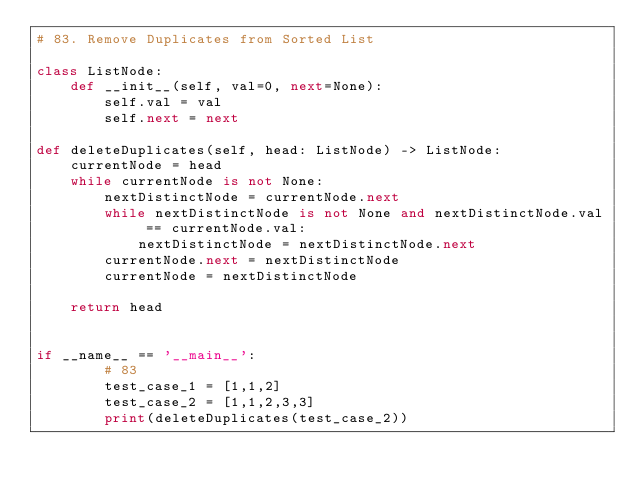Convert code to text. <code><loc_0><loc_0><loc_500><loc_500><_Python_># 83. Remove Duplicates from Sorted List

class ListNode:
    def __init__(self, val=0, next=None):
        self.val = val
        self.next = next

def deleteDuplicates(self, head: ListNode) -> ListNode:
    currentNode = head
    while currentNode is not None:
        nextDistinctNode = currentNode.next
        while nextDistinctNode is not None and nextDistinctNode.val == currentNode.val:
            nextDistinctNode = nextDistinctNode.next
        currentNode.next = nextDistinctNode
        currentNode = nextDistinctNode
    
    return head


if __name__ == '__main__':
        # 83
        test_case_1 = [1,1,2]
        test_case_2 = [1,1,2,3,3]
        print(deleteDuplicates(test_case_2))</code> 